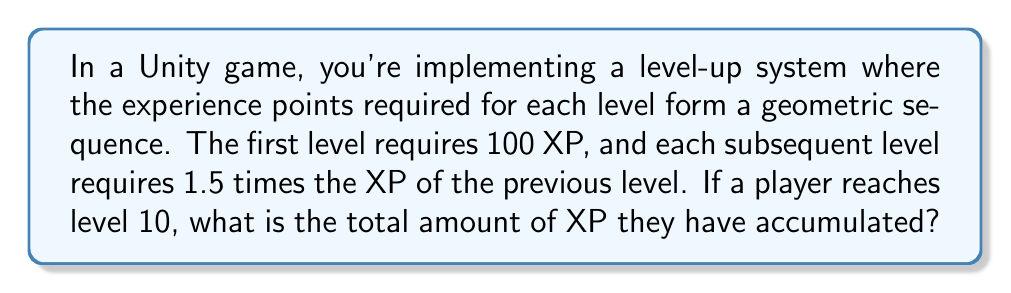Solve this math problem. Let's approach this step-by-step:

1) We're dealing with a geometric sequence where:
   $a_1 = 100$ (first term)
   $r = 1.5$ (common ratio)
   $n = 10$ (number of terms)

2) We need to find the sum of this geometric sequence. The formula for the sum of a geometric sequence is:

   $$S_n = \frac{a_1(1-r^n)}{1-r}$$

   Where $S_n$ is the sum of the first n terms.

3) Let's substitute our values:

   $$S_{10} = \frac{100(1-1.5^{10})}{1-1.5}$$

4) First, let's calculate $1.5^{10}$:
   
   $1.5^{10} \approx 57.665$

5) Now, let's substitute this back into our equation:

   $$S_{10} = \frac{100(1-57.665)}{1-1.5} = \frac{100(-56.665)}{-0.5}$$

6) Simplify:

   $$S_{10} = \frac{5666.5}{0.5} = 11,333$$

Therefore, the total XP accumulated by level 10 is 11,333.
Answer: 11,333 XP 